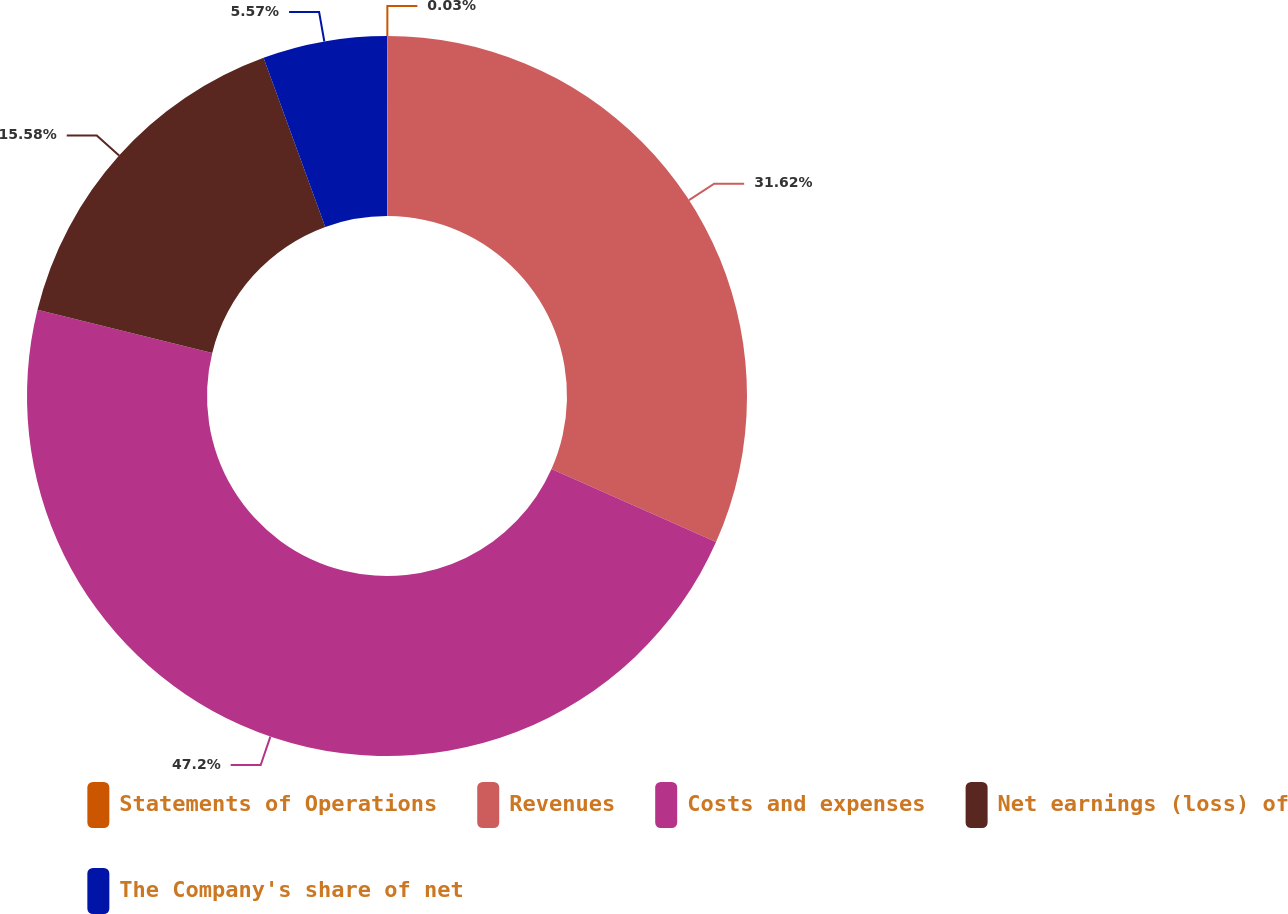<chart> <loc_0><loc_0><loc_500><loc_500><pie_chart><fcel>Statements of Operations<fcel>Revenues<fcel>Costs and expenses<fcel>Net earnings (loss) of<fcel>The Company's share of net<nl><fcel>0.03%<fcel>31.62%<fcel>47.2%<fcel>15.58%<fcel>5.57%<nl></chart> 